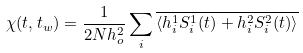<formula> <loc_0><loc_0><loc_500><loc_500>\chi ( t , t _ { w } ) = \frac { 1 } { 2 N h _ { o } ^ { 2 } } \sum _ { i } \overline { \langle h ^ { 1 } _ { i } S _ { i } ^ { 1 } ( t ) + h ^ { 2 } _ { i } S ^ { 2 } _ { i } ( t ) \rangle }</formula> 